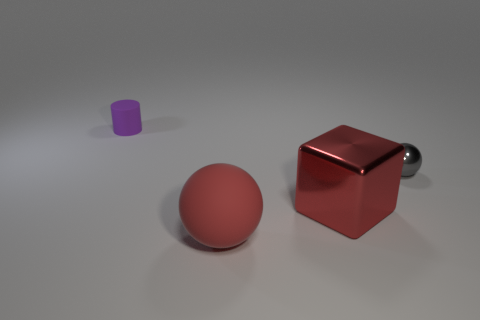There is a small thing left of the large matte sphere; what is it made of?
Your answer should be compact. Rubber. Does the tiny thing that is on the right side of the red cube have the same shape as the rubber object in front of the small rubber thing?
Make the answer very short. Yes. There is a object that is the same color as the big shiny block; what material is it?
Offer a terse response. Rubber. Are any tiny purple things visible?
Your answer should be compact. Yes. What is the material of the large thing that is the same shape as the tiny gray shiny object?
Your answer should be compact. Rubber. Are there any gray shiny things in front of the small gray thing?
Ensure brevity in your answer.  No. Is the material of the large object that is in front of the red metal thing the same as the gray object?
Keep it short and to the point. No. Is there a tiny matte object of the same color as the cylinder?
Your response must be concise. No. What shape is the red matte thing?
Ensure brevity in your answer.  Sphere. There is a thing that is on the left side of the large object left of the large red block; what is its color?
Keep it short and to the point. Purple. 